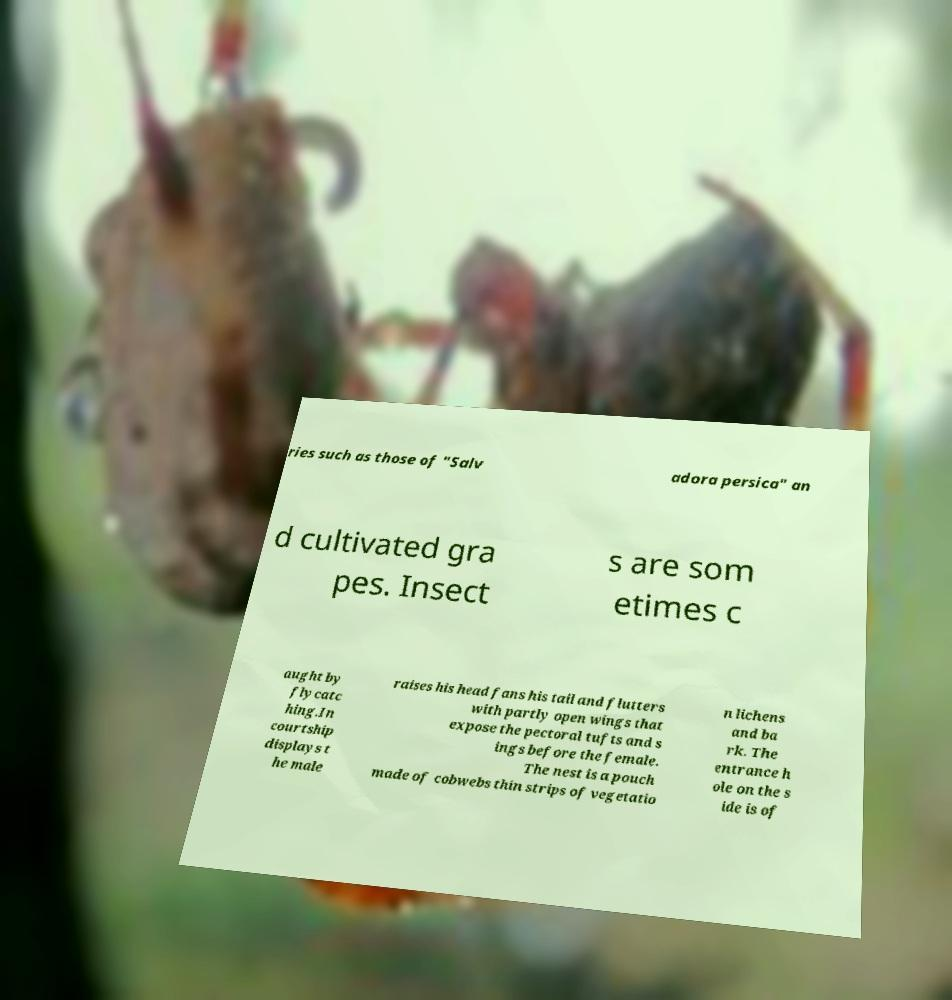Can you accurately transcribe the text from the provided image for me? ries such as those of "Salv adora persica" an d cultivated gra pes. Insect s are som etimes c aught by flycatc hing.In courtship displays t he male raises his head fans his tail and flutters with partly open wings that expose the pectoral tufts and s ings before the female. The nest is a pouch made of cobwebs thin strips of vegetatio n lichens and ba rk. The entrance h ole on the s ide is of 